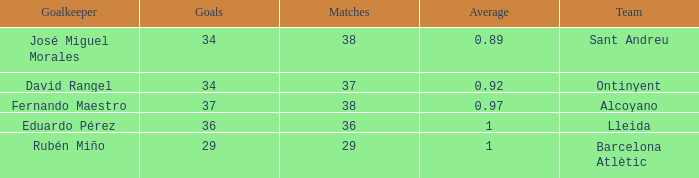When goals are 34 and matches are fewer than 37, what is the highest possible average? None. 